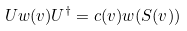<formula> <loc_0><loc_0><loc_500><loc_500>U w ( v ) U ^ { \dagger } = c ( v ) w ( S ( v ) )</formula> 